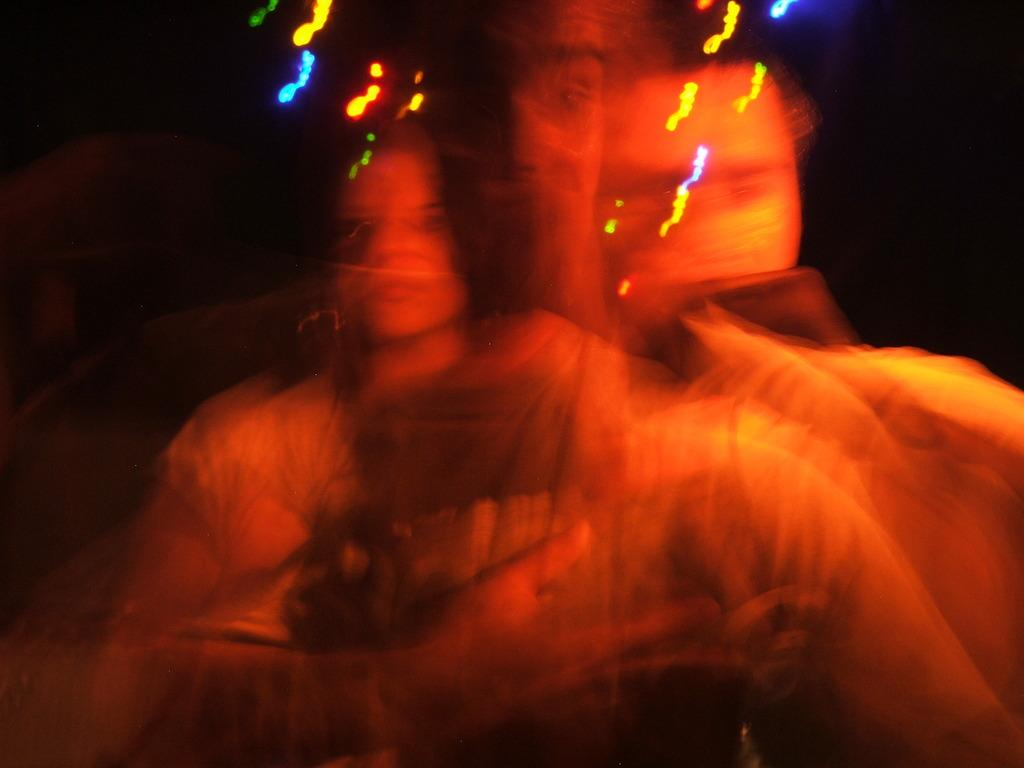How many individuals are present in the image? There are three people in the image. Can you describe the lighting in the image? The lighting in the image is noticeable. What can be observed about the background of the image? The background of the image is dark. Is there a stream of sugar flowing in the image? There is no stream of sugar present in the image. Can you recite a verse that is visible in the image? There is no verse present in the image. 